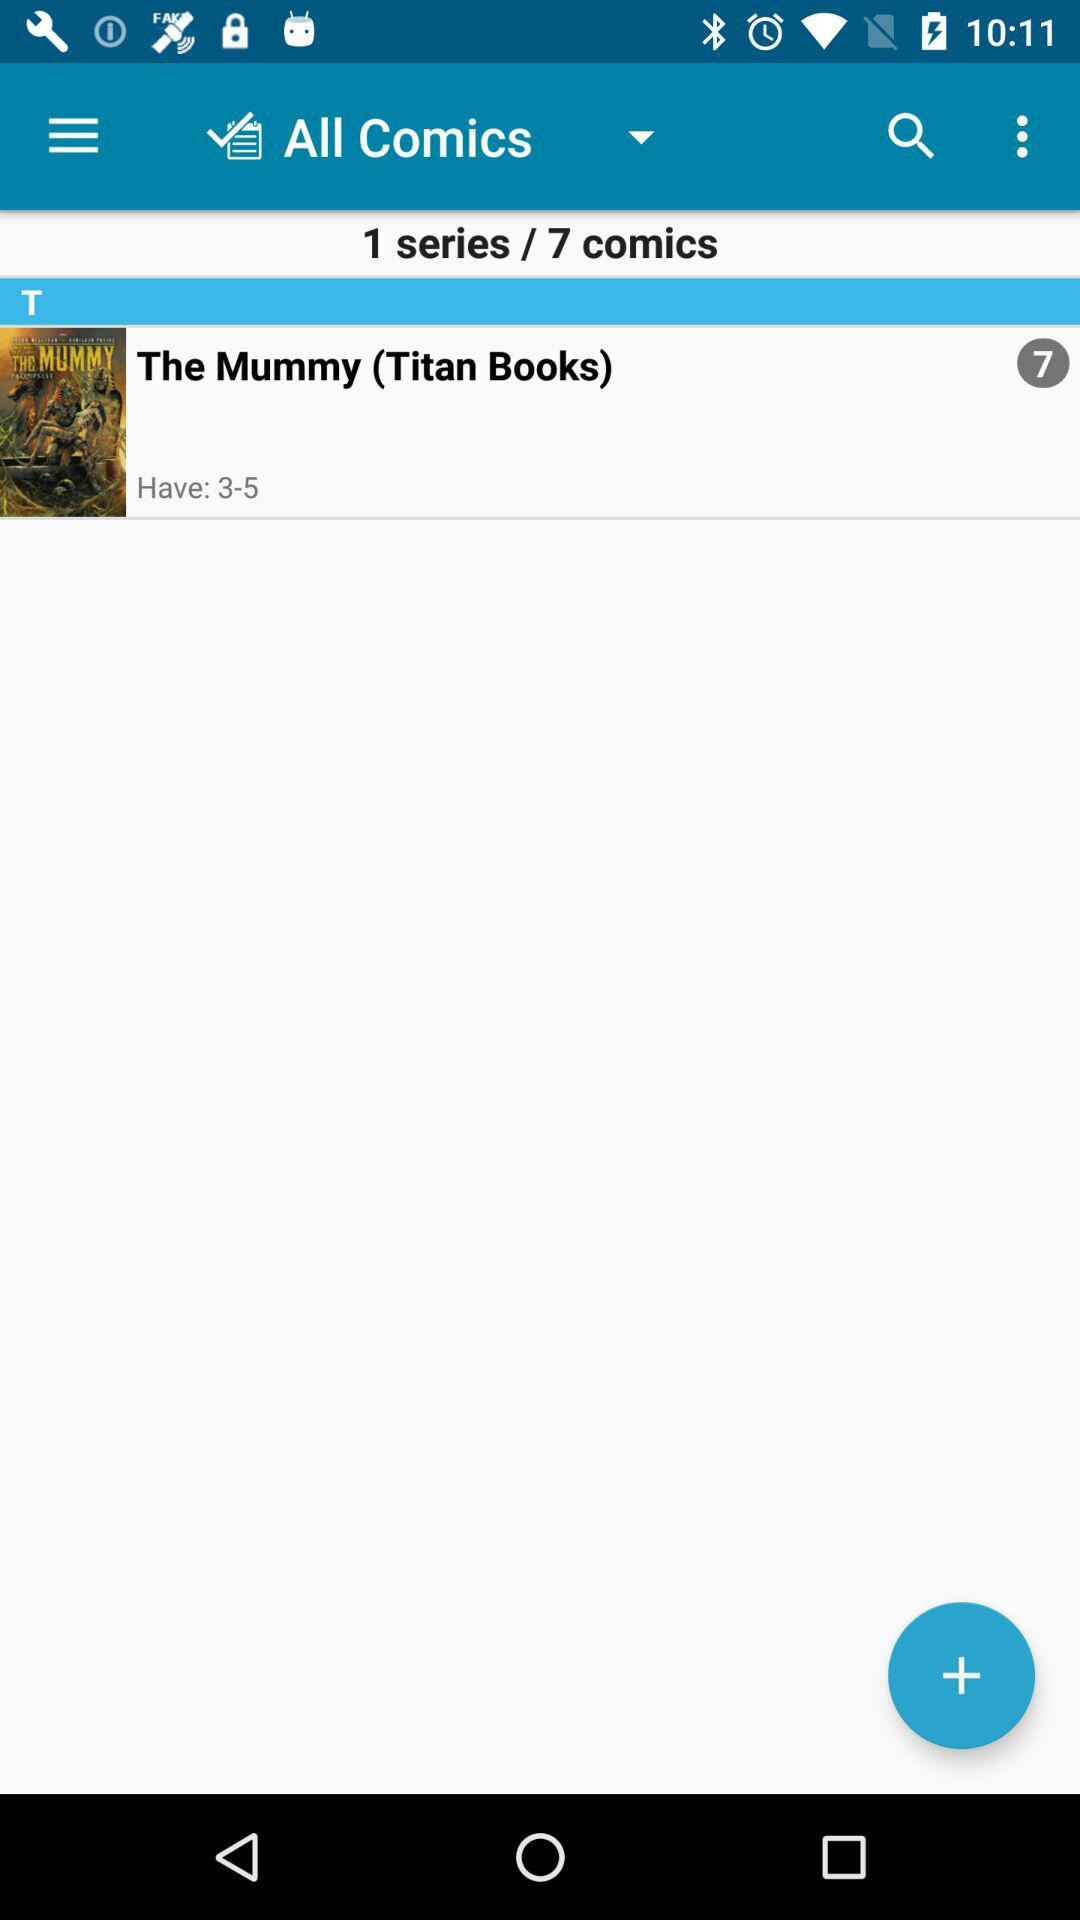How many series are there? There is 1 series. 